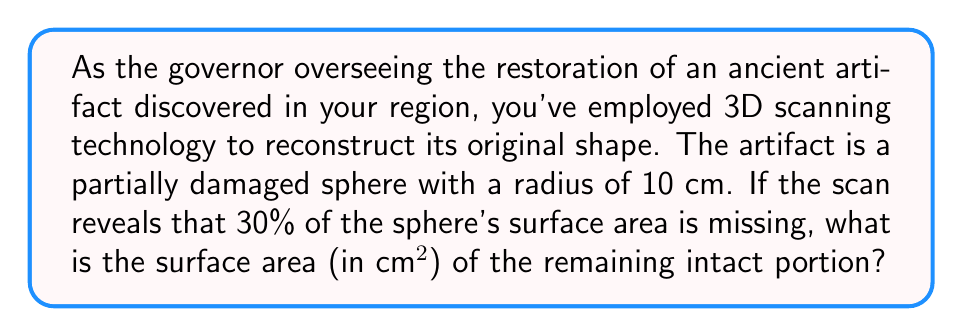Help me with this question. Let's approach this step-by-step:

1) First, recall the formula for the surface area of a sphere:
   $$ A = 4\pi r^2 $$

2) Given the radius $r = 10$ cm, we can calculate the total surface area:
   $$ A_{total} = 4\pi (10)^2 = 400\pi \text{ cm}^2 $$

3) We're told that 30% of the surface area is missing. This means 70% is intact.

4) To find the intact surface area, we multiply the total area by 0.70:
   $$ A_{intact} = 400\pi \times 0.70 = 280\pi \text{ cm}^2 $$

5) Simplify:
   $$ A_{intact} = 280\pi \approx 879.65 \text{ cm}^2 $$

6) Rounding to the nearest whole number:
   $$ A_{intact} \approx 880 \text{ cm}^2 $$

This result represents the surface area of the remaining intact portion of the artifact.
Answer: 880 cm² 